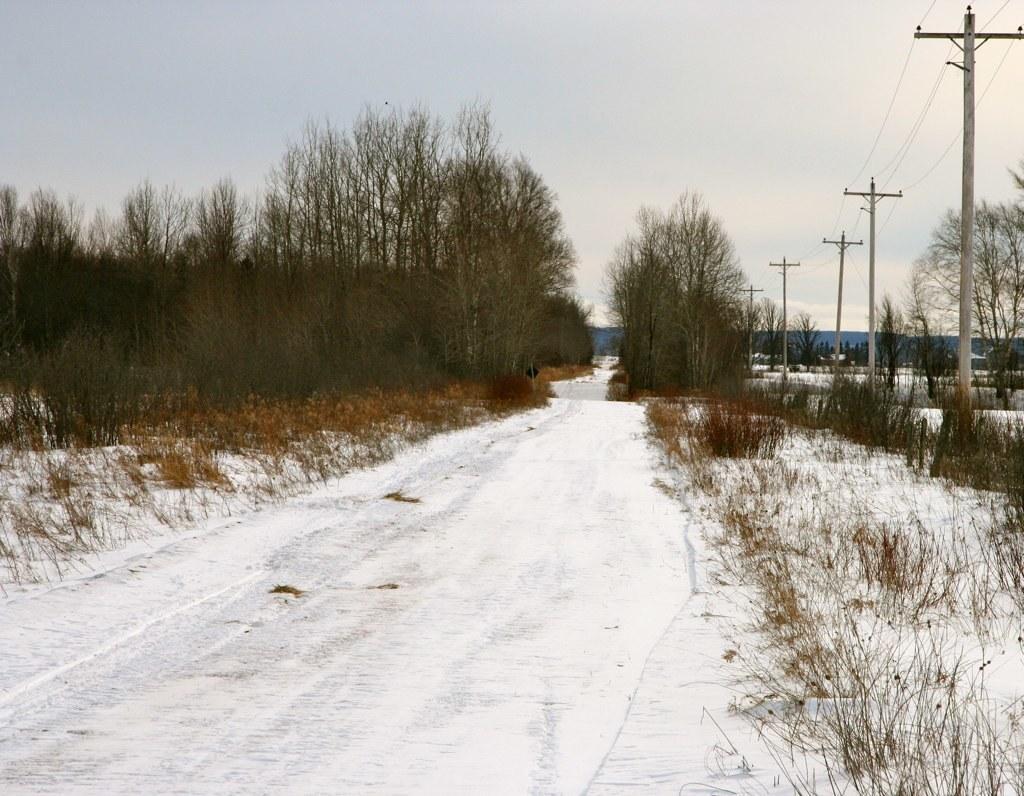Could you give a brief overview of what you see in this image? In this image I can see snow which is in white color. Background I can see trees in green color, few electric poles and sky is in white color. 